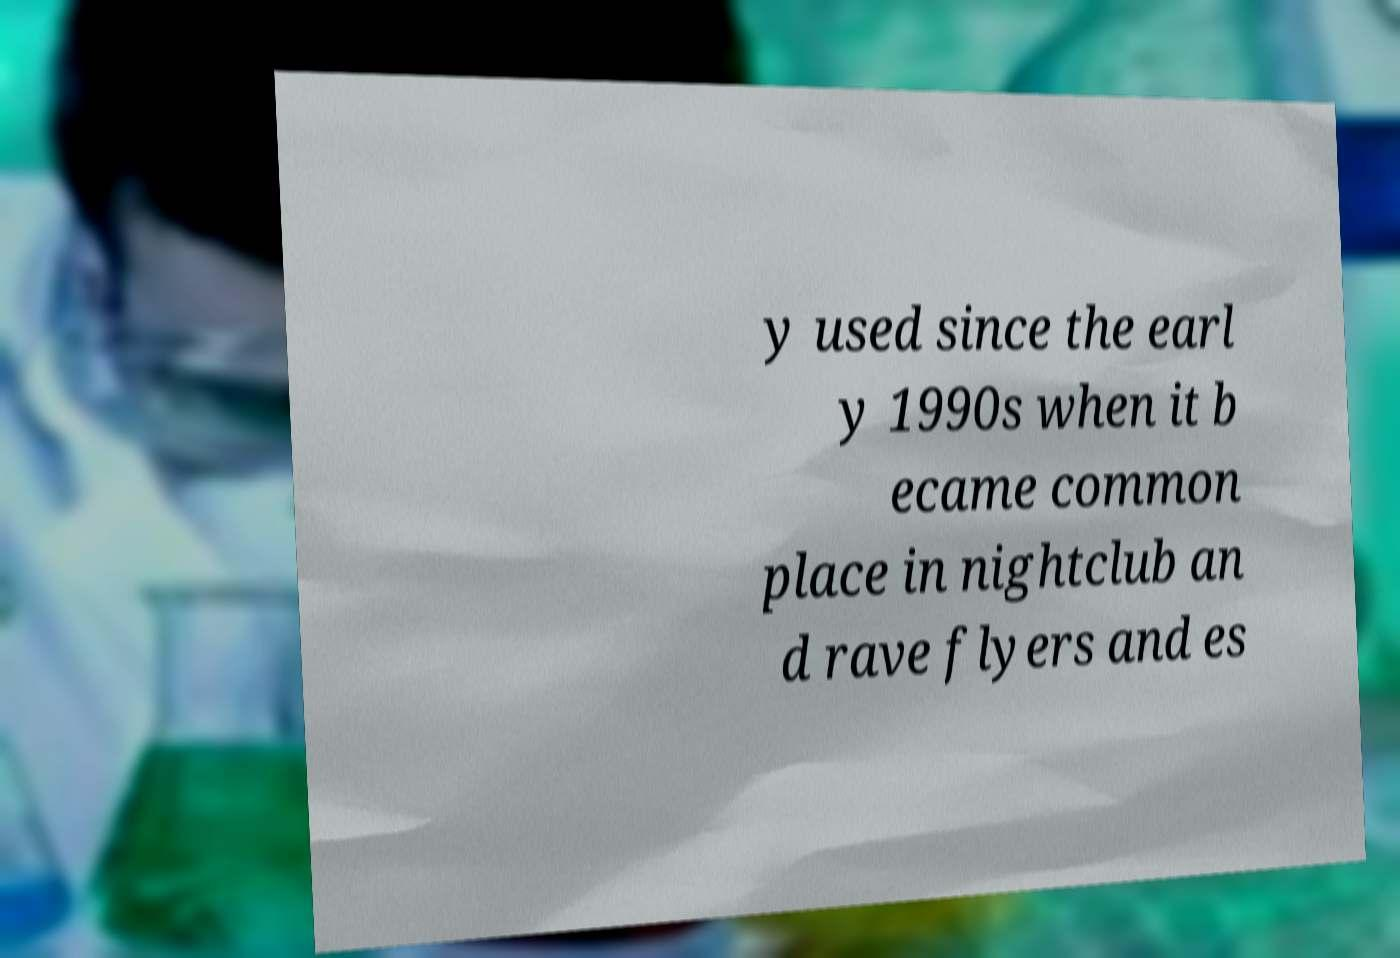I need the written content from this picture converted into text. Can you do that? y used since the earl y 1990s when it b ecame common place in nightclub an d rave flyers and es 